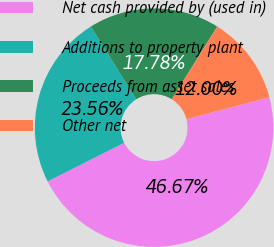Convert chart. <chart><loc_0><loc_0><loc_500><loc_500><pie_chart><fcel>Net cash provided by (used in)<fcel>Additions to property plant<fcel>Proceeds from asset sales<fcel>Other net<nl><fcel>46.67%<fcel>23.56%<fcel>17.78%<fcel>12.0%<nl></chart> 